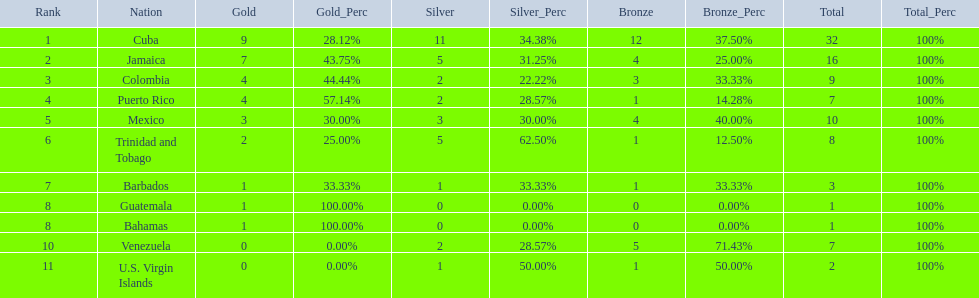Which 3 countries were awarded the most medals? Cuba, Jamaica, Colombia. Of these 3 countries which ones are islands? Cuba, Jamaica. Which one won the most silver medals? Cuba. 